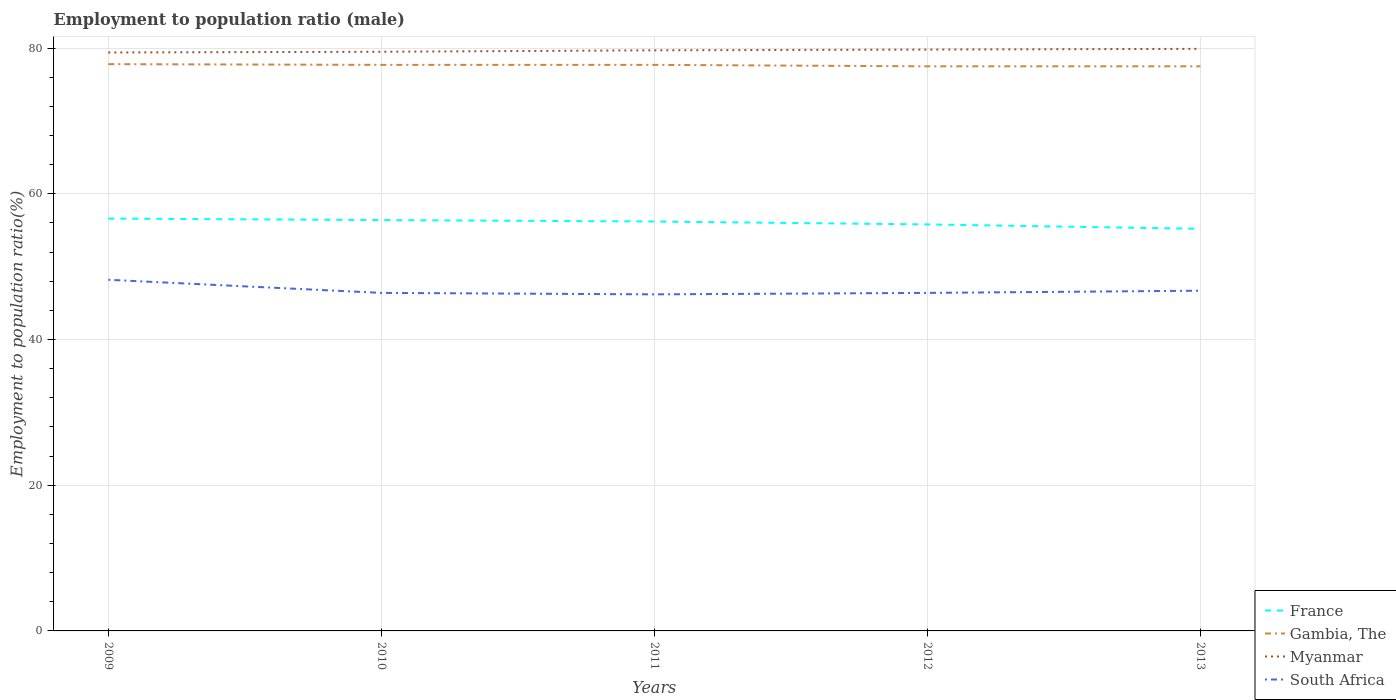Is the number of lines equal to the number of legend labels?
Keep it short and to the point. Yes. Across all years, what is the maximum employment to population ratio in Gambia, The?
Your answer should be very brief. 77.5. What is the total employment to population ratio in Gambia, The in the graph?
Provide a short and direct response. 0.2. What is the difference between the highest and the second highest employment to population ratio in Gambia, The?
Keep it short and to the point. 0.3. What is the difference between the highest and the lowest employment to population ratio in South Africa?
Provide a short and direct response. 1. How many years are there in the graph?
Your answer should be very brief. 5. What is the difference between two consecutive major ticks on the Y-axis?
Your response must be concise. 20. Does the graph contain any zero values?
Provide a succinct answer. No. Does the graph contain grids?
Your answer should be very brief. Yes. How many legend labels are there?
Give a very brief answer. 4. How are the legend labels stacked?
Make the answer very short. Vertical. What is the title of the graph?
Give a very brief answer. Employment to population ratio (male). Does "Other small states" appear as one of the legend labels in the graph?
Offer a very short reply. No. What is the label or title of the Y-axis?
Your answer should be compact. Employment to population ratio(%). What is the Employment to population ratio(%) of France in 2009?
Keep it short and to the point. 56.6. What is the Employment to population ratio(%) of Gambia, The in 2009?
Your response must be concise. 77.8. What is the Employment to population ratio(%) in Myanmar in 2009?
Provide a short and direct response. 79.4. What is the Employment to population ratio(%) of South Africa in 2009?
Your response must be concise. 48.2. What is the Employment to population ratio(%) in France in 2010?
Your response must be concise. 56.4. What is the Employment to population ratio(%) in Gambia, The in 2010?
Ensure brevity in your answer.  77.7. What is the Employment to population ratio(%) of Myanmar in 2010?
Your response must be concise. 79.5. What is the Employment to population ratio(%) of South Africa in 2010?
Your answer should be compact. 46.4. What is the Employment to population ratio(%) of France in 2011?
Your answer should be compact. 56.2. What is the Employment to population ratio(%) in Gambia, The in 2011?
Offer a terse response. 77.7. What is the Employment to population ratio(%) in Myanmar in 2011?
Ensure brevity in your answer.  79.7. What is the Employment to population ratio(%) of South Africa in 2011?
Your response must be concise. 46.2. What is the Employment to population ratio(%) of France in 2012?
Your answer should be very brief. 55.8. What is the Employment to population ratio(%) of Gambia, The in 2012?
Give a very brief answer. 77.5. What is the Employment to population ratio(%) of Myanmar in 2012?
Give a very brief answer. 79.8. What is the Employment to population ratio(%) of South Africa in 2012?
Make the answer very short. 46.4. What is the Employment to population ratio(%) in France in 2013?
Your answer should be compact. 55.2. What is the Employment to population ratio(%) of Gambia, The in 2013?
Ensure brevity in your answer.  77.5. What is the Employment to population ratio(%) of Myanmar in 2013?
Offer a very short reply. 79.9. What is the Employment to population ratio(%) of South Africa in 2013?
Ensure brevity in your answer.  46.7. Across all years, what is the maximum Employment to population ratio(%) in France?
Make the answer very short. 56.6. Across all years, what is the maximum Employment to population ratio(%) of Gambia, The?
Make the answer very short. 77.8. Across all years, what is the maximum Employment to population ratio(%) of Myanmar?
Ensure brevity in your answer.  79.9. Across all years, what is the maximum Employment to population ratio(%) in South Africa?
Your answer should be very brief. 48.2. Across all years, what is the minimum Employment to population ratio(%) of France?
Make the answer very short. 55.2. Across all years, what is the minimum Employment to population ratio(%) of Gambia, The?
Provide a short and direct response. 77.5. Across all years, what is the minimum Employment to population ratio(%) of Myanmar?
Offer a very short reply. 79.4. Across all years, what is the minimum Employment to population ratio(%) of South Africa?
Your response must be concise. 46.2. What is the total Employment to population ratio(%) in France in the graph?
Your response must be concise. 280.2. What is the total Employment to population ratio(%) in Gambia, The in the graph?
Make the answer very short. 388.2. What is the total Employment to population ratio(%) in Myanmar in the graph?
Your response must be concise. 398.3. What is the total Employment to population ratio(%) in South Africa in the graph?
Keep it short and to the point. 233.9. What is the difference between the Employment to population ratio(%) of France in 2009 and that in 2010?
Your answer should be very brief. 0.2. What is the difference between the Employment to population ratio(%) of Gambia, The in 2009 and that in 2011?
Keep it short and to the point. 0.1. What is the difference between the Employment to population ratio(%) of Myanmar in 2009 and that in 2012?
Provide a short and direct response. -0.4. What is the difference between the Employment to population ratio(%) in South Africa in 2009 and that in 2012?
Keep it short and to the point. 1.8. What is the difference between the Employment to population ratio(%) in Gambia, The in 2009 and that in 2013?
Your response must be concise. 0.3. What is the difference between the Employment to population ratio(%) in Myanmar in 2009 and that in 2013?
Offer a very short reply. -0.5. What is the difference between the Employment to population ratio(%) of Myanmar in 2010 and that in 2011?
Offer a terse response. -0.2. What is the difference between the Employment to population ratio(%) in France in 2010 and that in 2012?
Provide a short and direct response. 0.6. What is the difference between the Employment to population ratio(%) of Gambia, The in 2010 and that in 2013?
Your response must be concise. 0.2. What is the difference between the Employment to population ratio(%) in South Africa in 2010 and that in 2013?
Provide a succinct answer. -0.3. What is the difference between the Employment to population ratio(%) of France in 2011 and that in 2013?
Your answer should be compact. 1. What is the difference between the Employment to population ratio(%) in Myanmar in 2011 and that in 2013?
Give a very brief answer. -0.2. What is the difference between the Employment to population ratio(%) in Myanmar in 2012 and that in 2013?
Offer a very short reply. -0.1. What is the difference between the Employment to population ratio(%) in France in 2009 and the Employment to population ratio(%) in Gambia, The in 2010?
Your answer should be very brief. -21.1. What is the difference between the Employment to population ratio(%) of France in 2009 and the Employment to population ratio(%) of Myanmar in 2010?
Your answer should be very brief. -22.9. What is the difference between the Employment to population ratio(%) in Gambia, The in 2009 and the Employment to population ratio(%) in Myanmar in 2010?
Offer a terse response. -1.7. What is the difference between the Employment to population ratio(%) of Gambia, The in 2009 and the Employment to population ratio(%) of South Africa in 2010?
Offer a terse response. 31.4. What is the difference between the Employment to population ratio(%) of France in 2009 and the Employment to population ratio(%) of Gambia, The in 2011?
Your answer should be very brief. -21.1. What is the difference between the Employment to population ratio(%) in France in 2009 and the Employment to population ratio(%) in Myanmar in 2011?
Keep it short and to the point. -23.1. What is the difference between the Employment to population ratio(%) in France in 2009 and the Employment to population ratio(%) in South Africa in 2011?
Keep it short and to the point. 10.4. What is the difference between the Employment to population ratio(%) of Gambia, The in 2009 and the Employment to population ratio(%) of South Africa in 2011?
Ensure brevity in your answer.  31.6. What is the difference between the Employment to population ratio(%) of Myanmar in 2009 and the Employment to population ratio(%) of South Africa in 2011?
Your answer should be compact. 33.2. What is the difference between the Employment to population ratio(%) in France in 2009 and the Employment to population ratio(%) in Gambia, The in 2012?
Keep it short and to the point. -20.9. What is the difference between the Employment to population ratio(%) of France in 2009 and the Employment to population ratio(%) of Myanmar in 2012?
Ensure brevity in your answer.  -23.2. What is the difference between the Employment to population ratio(%) of Gambia, The in 2009 and the Employment to population ratio(%) of South Africa in 2012?
Offer a terse response. 31.4. What is the difference between the Employment to population ratio(%) in France in 2009 and the Employment to population ratio(%) in Gambia, The in 2013?
Ensure brevity in your answer.  -20.9. What is the difference between the Employment to population ratio(%) of France in 2009 and the Employment to population ratio(%) of Myanmar in 2013?
Provide a short and direct response. -23.3. What is the difference between the Employment to population ratio(%) of France in 2009 and the Employment to population ratio(%) of South Africa in 2013?
Offer a terse response. 9.9. What is the difference between the Employment to population ratio(%) in Gambia, The in 2009 and the Employment to population ratio(%) in Myanmar in 2013?
Ensure brevity in your answer.  -2.1. What is the difference between the Employment to population ratio(%) in Gambia, The in 2009 and the Employment to population ratio(%) in South Africa in 2013?
Your response must be concise. 31.1. What is the difference between the Employment to population ratio(%) in Myanmar in 2009 and the Employment to population ratio(%) in South Africa in 2013?
Your answer should be very brief. 32.7. What is the difference between the Employment to population ratio(%) of France in 2010 and the Employment to population ratio(%) of Gambia, The in 2011?
Give a very brief answer. -21.3. What is the difference between the Employment to population ratio(%) of France in 2010 and the Employment to population ratio(%) of Myanmar in 2011?
Keep it short and to the point. -23.3. What is the difference between the Employment to population ratio(%) of France in 2010 and the Employment to population ratio(%) of South Africa in 2011?
Provide a short and direct response. 10.2. What is the difference between the Employment to population ratio(%) of Gambia, The in 2010 and the Employment to population ratio(%) of Myanmar in 2011?
Make the answer very short. -2. What is the difference between the Employment to population ratio(%) of Gambia, The in 2010 and the Employment to population ratio(%) of South Africa in 2011?
Keep it short and to the point. 31.5. What is the difference between the Employment to population ratio(%) in Myanmar in 2010 and the Employment to population ratio(%) in South Africa in 2011?
Provide a succinct answer. 33.3. What is the difference between the Employment to population ratio(%) in France in 2010 and the Employment to population ratio(%) in Gambia, The in 2012?
Keep it short and to the point. -21.1. What is the difference between the Employment to population ratio(%) in France in 2010 and the Employment to population ratio(%) in Myanmar in 2012?
Give a very brief answer. -23.4. What is the difference between the Employment to population ratio(%) in France in 2010 and the Employment to population ratio(%) in South Africa in 2012?
Offer a very short reply. 10. What is the difference between the Employment to population ratio(%) in Gambia, The in 2010 and the Employment to population ratio(%) in South Africa in 2012?
Ensure brevity in your answer.  31.3. What is the difference between the Employment to population ratio(%) in Myanmar in 2010 and the Employment to population ratio(%) in South Africa in 2012?
Offer a very short reply. 33.1. What is the difference between the Employment to population ratio(%) in France in 2010 and the Employment to population ratio(%) in Gambia, The in 2013?
Offer a very short reply. -21.1. What is the difference between the Employment to population ratio(%) of France in 2010 and the Employment to population ratio(%) of Myanmar in 2013?
Offer a very short reply. -23.5. What is the difference between the Employment to population ratio(%) of Gambia, The in 2010 and the Employment to population ratio(%) of Myanmar in 2013?
Offer a terse response. -2.2. What is the difference between the Employment to population ratio(%) of Myanmar in 2010 and the Employment to population ratio(%) of South Africa in 2013?
Give a very brief answer. 32.8. What is the difference between the Employment to population ratio(%) of France in 2011 and the Employment to population ratio(%) of Gambia, The in 2012?
Provide a short and direct response. -21.3. What is the difference between the Employment to population ratio(%) of France in 2011 and the Employment to population ratio(%) of Myanmar in 2012?
Your answer should be compact. -23.6. What is the difference between the Employment to population ratio(%) in France in 2011 and the Employment to population ratio(%) in South Africa in 2012?
Offer a terse response. 9.8. What is the difference between the Employment to population ratio(%) in Gambia, The in 2011 and the Employment to population ratio(%) in Myanmar in 2012?
Offer a very short reply. -2.1. What is the difference between the Employment to population ratio(%) of Gambia, The in 2011 and the Employment to population ratio(%) of South Africa in 2012?
Make the answer very short. 31.3. What is the difference between the Employment to population ratio(%) in Myanmar in 2011 and the Employment to population ratio(%) in South Africa in 2012?
Provide a succinct answer. 33.3. What is the difference between the Employment to population ratio(%) in France in 2011 and the Employment to population ratio(%) in Gambia, The in 2013?
Keep it short and to the point. -21.3. What is the difference between the Employment to population ratio(%) of France in 2011 and the Employment to population ratio(%) of Myanmar in 2013?
Provide a short and direct response. -23.7. What is the difference between the Employment to population ratio(%) of France in 2011 and the Employment to population ratio(%) of South Africa in 2013?
Ensure brevity in your answer.  9.5. What is the difference between the Employment to population ratio(%) in Gambia, The in 2011 and the Employment to population ratio(%) in South Africa in 2013?
Ensure brevity in your answer.  31. What is the difference between the Employment to population ratio(%) of France in 2012 and the Employment to population ratio(%) of Gambia, The in 2013?
Your response must be concise. -21.7. What is the difference between the Employment to population ratio(%) of France in 2012 and the Employment to population ratio(%) of Myanmar in 2013?
Offer a very short reply. -24.1. What is the difference between the Employment to population ratio(%) in France in 2012 and the Employment to population ratio(%) in South Africa in 2013?
Make the answer very short. 9.1. What is the difference between the Employment to population ratio(%) of Gambia, The in 2012 and the Employment to population ratio(%) of Myanmar in 2013?
Give a very brief answer. -2.4. What is the difference between the Employment to population ratio(%) of Gambia, The in 2012 and the Employment to population ratio(%) of South Africa in 2013?
Provide a succinct answer. 30.8. What is the difference between the Employment to population ratio(%) of Myanmar in 2012 and the Employment to population ratio(%) of South Africa in 2013?
Offer a terse response. 33.1. What is the average Employment to population ratio(%) in France per year?
Your answer should be compact. 56.04. What is the average Employment to population ratio(%) of Gambia, The per year?
Provide a succinct answer. 77.64. What is the average Employment to population ratio(%) of Myanmar per year?
Give a very brief answer. 79.66. What is the average Employment to population ratio(%) in South Africa per year?
Keep it short and to the point. 46.78. In the year 2009, what is the difference between the Employment to population ratio(%) in France and Employment to population ratio(%) in Gambia, The?
Keep it short and to the point. -21.2. In the year 2009, what is the difference between the Employment to population ratio(%) of France and Employment to population ratio(%) of Myanmar?
Offer a very short reply. -22.8. In the year 2009, what is the difference between the Employment to population ratio(%) of France and Employment to population ratio(%) of South Africa?
Offer a very short reply. 8.4. In the year 2009, what is the difference between the Employment to population ratio(%) in Gambia, The and Employment to population ratio(%) in South Africa?
Provide a succinct answer. 29.6. In the year 2009, what is the difference between the Employment to population ratio(%) in Myanmar and Employment to population ratio(%) in South Africa?
Offer a terse response. 31.2. In the year 2010, what is the difference between the Employment to population ratio(%) of France and Employment to population ratio(%) of Gambia, The?
Keep it short and to the point. -21.3. In the year 2010, what is the difference between the Employment to population ratio(%) of France and Employment to population ratio(%) of Myanmar?
Offer a very short reply. -23.1. In the year 2010, what is the difference between the Employment to population ratio(%) of Gambia, The and Employment to population ratio(%) of South Africa?
Your answer should be compact. 31.3. In the year 2010, what is the difference between the Employment to population ratio(%) in Myanmar and Employment to population ratio(%) in South Africa?
Provide a short and direct response. 33.1. In the year 2011, what is the difference between the Employment to population ratio(%) in France and Employment to population ratio(%) in Gambia, The?
Make the answer very short. -21.5. In the year 2011, what is the difference between the Employment to population ratio(%) of France and Employment to population ratio(%) of Myanmar?
Provide a short and direct response. -23.5. In the year 2011, what is the difference between the Employment to population ratio(%) in Gambia, The and Employment to population ratio(%) in Myanmar?
Keep it short and to the point. -2. In the year 2011, what is the difference between the Employment to population ratio(%) in Gambia, The and Employment to population ratio(%) in South Africa?
Your answer should be compact. 31.5. In the year 2011, what is the difference between the Employment to population ratio(%) of Myanmar and Employment to population ratio(%) of South Africa?
Your response must be concise. 33.5. In the year 2012, what is the difference between the Employment to population ratio(%) of France and Employment to population ratio(%) of Gambia, The?
Make the answer very short. -21.7. In the year 2012, what is the difference between the Employment to population ratio(%) of Gambia, The and Employment to population ratio(%) of South Africa?
Your response must be concise. 31.1. In the year 2012, what is the difference between the Employment to population ratio(%) in Myanmar and Employment to population ratio(%) in South Africa?
Offer a terse response. 33.4. In the year 2013, what is the difference between the Employment to population ratio(%) of France and Employment to population ratio(%) of Gambia, The?
Your response must be concise. -22.3. In the year 2013, what is the difference between the Employment to population ratio(%) of France and Employment to population ratio(%) of Myanmar?
Give a very brief answer. -24.7. In the year 2013, what is the difference between the Employment to population ratio(%) in France and Employment to population ratio(%) in South Africa?
Your response must be concise. 8.5. In the year 2013, what is the difference between the Employment to population ratio(%) in Gambia, The and Employment to population ratio(%) in South Africa?
Your response must be concise. 30.8. In the year 2013, what is the difference between the Employment to population ratio(%) of Myanmar and Employment to population ratio(%) of South Africa?
Offer a terse response. 33.2. What is the ratio of the Employment to population ratio(%) of France in 2009 to that in 2010?
Your answer should be compact. 1. What is the ratio of the Employment to population ratio(%) of Gambia, The in 2009 to that in 2010?
Make the answer very short. 1. What is the ratio of the Employment to population ratio(%) in South Africa in 2009 to that in 2010?
Offer a very short reply. 1.04. What is the ratio of the Employment to population ratio(%) in France in 2009 to that in 2011?
Provide a short and direct response. 1.01. What is the ratio of the Employment to population ratio(%) of Myanmar in 2009 to that in 2011?
Provide a short and direct response. 1. What is the ratio of the Employment to population ratio(%) of South Africa in 2009 to that in 2011?
Ensure brevity in your answer.  1.04. What is the ratio of the Employment to population ratio(%) of France in 2009 to that in 2012?
Keep it short and to the point. 1.01. What is the ratio of the Employment to population ratio(%) of Gambia, The in 2009 to that in 2012?
Your response must be concise. 1. What is the ratio of the Employment to population ratio(%) in South Africa in 2009 to that in 2012?
Give a very brief answer. 1.04. What is the ratio of the Employment to population ratio(%) in France in 2009 to that in 2013?
Offer a very short reply. 1.03. What is the ratio of the Employment to population ratio(%) in Gambia, The in 2009 to that in 2013?
Make the answer very short. 1. What is the ratio of the Employment to population ratio(%) in Myanmar in 2009 to that in 2013?
Offer a terse response. 0.99. What is the ratio of the Employment to population ratio(%) in South Africa in 2009 to that in 2013?
Offer a very short reply. 1.03. What is the ratio of the Employment to population ratio(%) in France in 2010 to that in 2012?
Provide a succinct answer. 1.01. What is the ratio of the Employment to population ratio(%) of Myanmar in 2010 to that in 2012?
Provide a short and direct response. 1. What is the ratio of the Employment to population ratio(%) of South Africa in 2010 to that in 2012?
Your response must be concise. 1. What is the ratio of the Employment to population ratio(%) in France in 2010 to that in 2013?
Keep it short and to the point. 1.02. What is the ratio of the Employment to population ratio(%) of Myanmar in 2010 to that in 2013?
Ensure brevity in your answer.  0.99. What is the ratio of the Employment to population ratio(%) of South Africa in 2010 to that in 2013?
Ensure brevity in your answer.  0.99. What is the ratio of the Employment to population ratio(%) of Myanmar in 2011 to that in 2012?
Keep it short and to the point. 1. What is the ratio of the Employment to population ratio(%) of South Africa in 2011 to that in 2012?
Ensure brevity in your answer.  1. What is the ratio of the Employment to population ratio(%) of France in 2011 to that in 2013?
Ensure brevity in your answer.  1.02. What is the ratio of the Employment to population ratio(%) in South Africa in 2011 to that in 2013?
Your answer should be very brief. 0.99. What is the ratio of the Employment to population ratio(%) in France in 2012 to that in 2013?
Your response must be concise. 1.01. What is the ratio of the Employment to population ratio(%) of Gambia, The in 2012 to that in 2013?
Provide a succinct answer. 1. What is the ratio of the Employment to population ratio(%) in Myanmar in 2012 to that in 2013?
Your answer should be very brief. 1. What is the difference between the highest and the second highest Employment to population ratio(%) of Gambia, The?
Make the answer very short. 0.1. What is the difference between the highest and the second highest Employment to population ratio(%) of South Africa?
Your answer should be very brief. 1.5. 